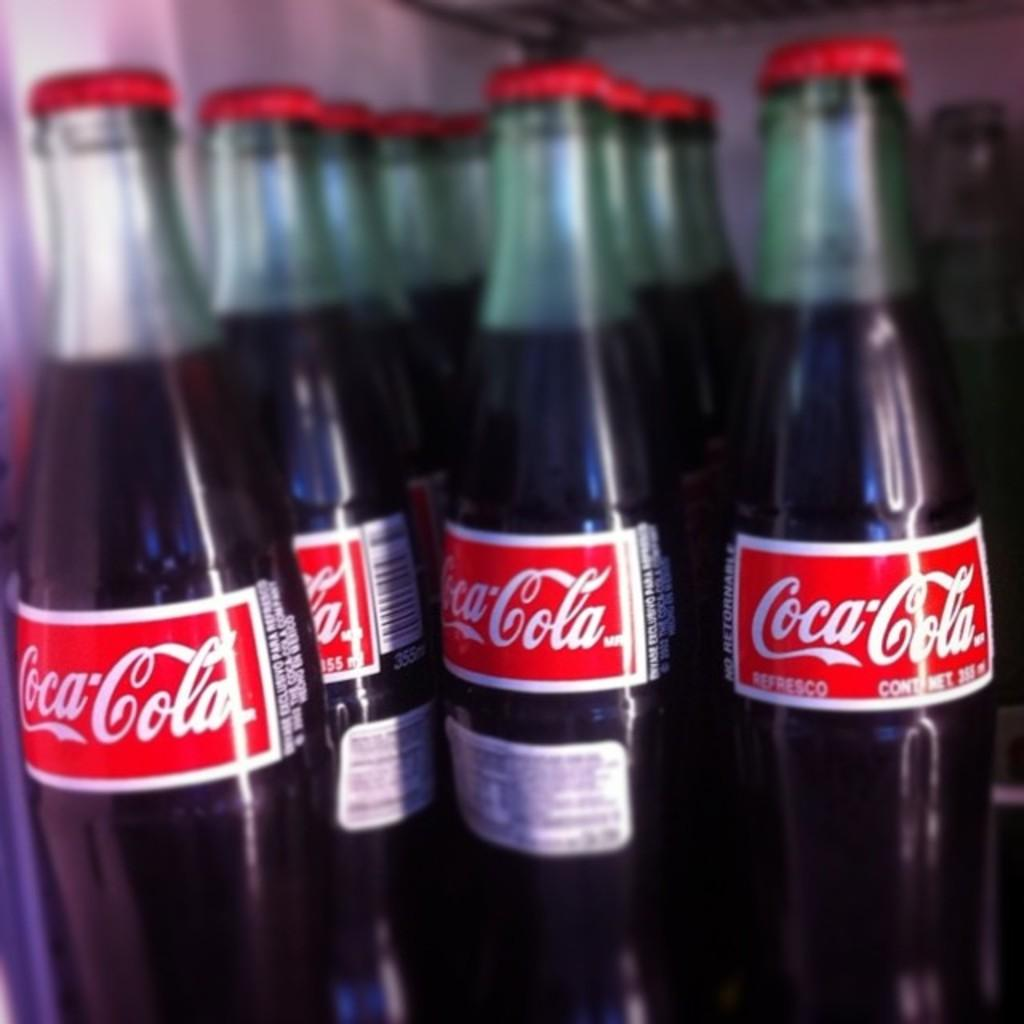What type of bottles are visible in the image? There are labeled as Coca Cola in the image. Can you describe the label on the bottles? The label on the bottles says "Coca Cola." What type of root can be seen growing from the heart in the image? There is no root or heart present in the image; it only features bottles labeled as Coca Cola. 